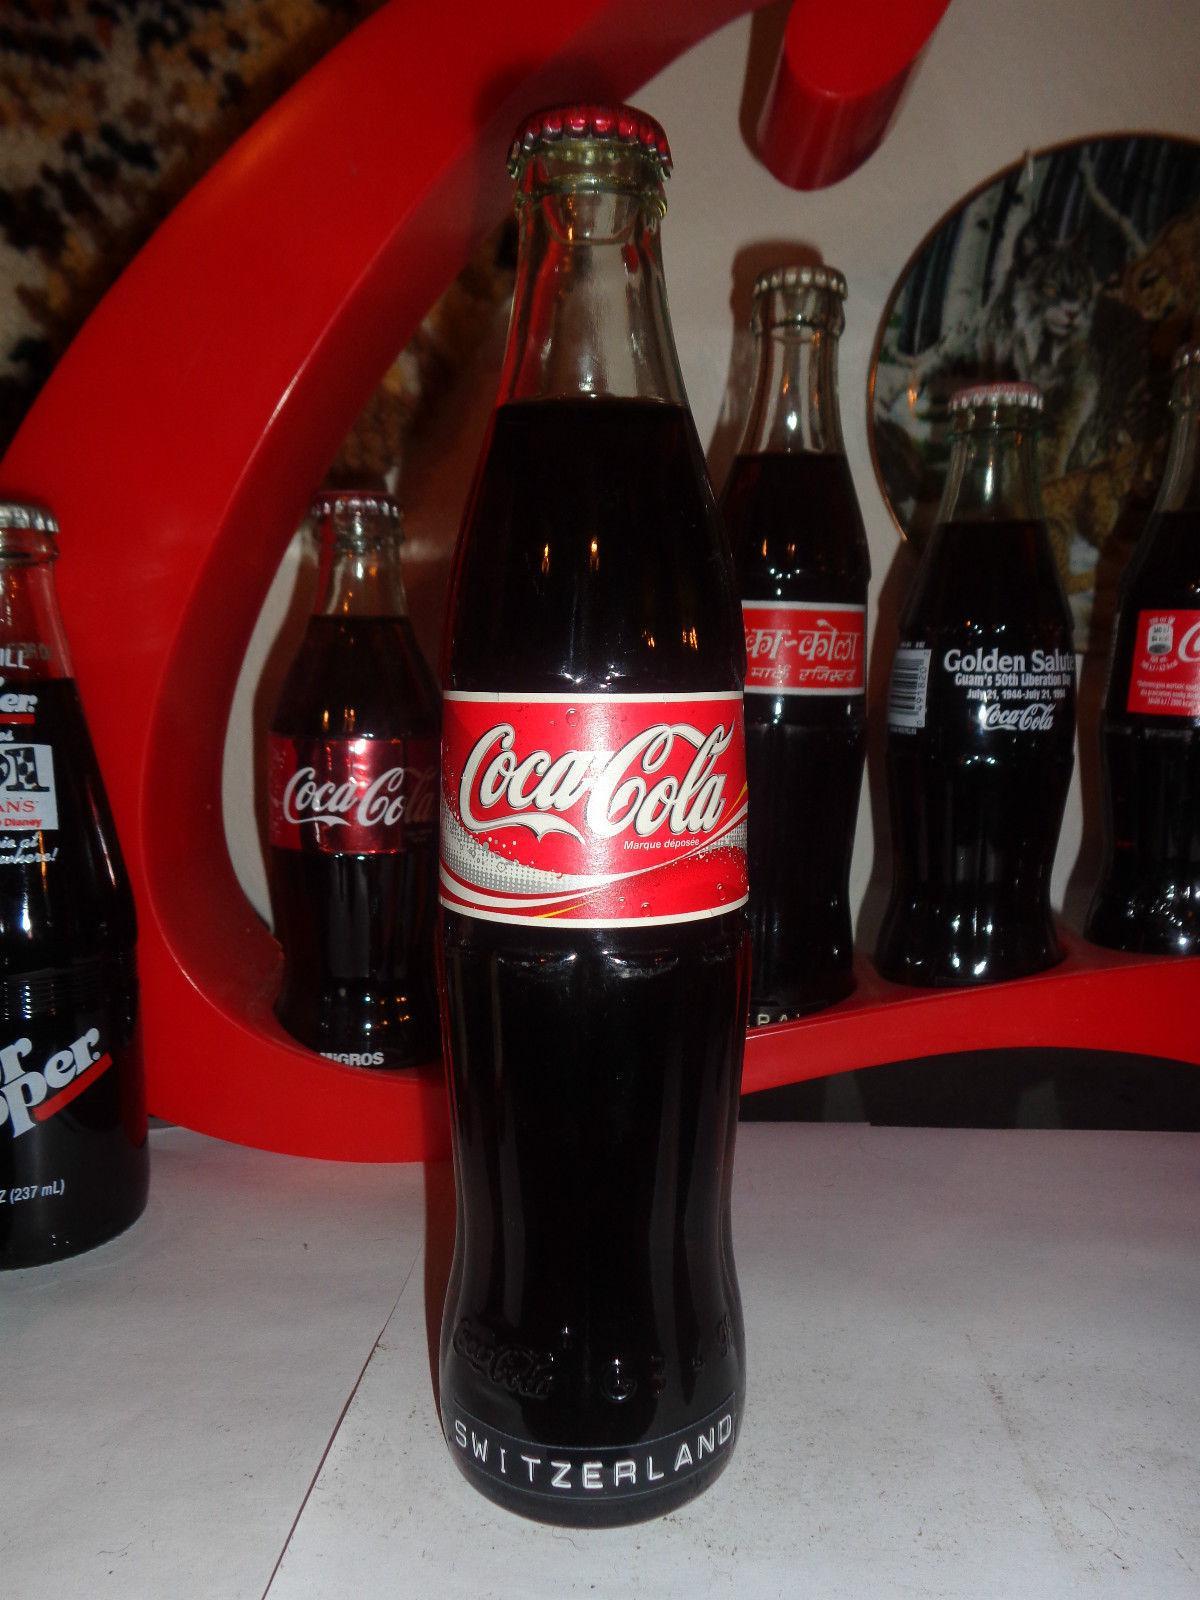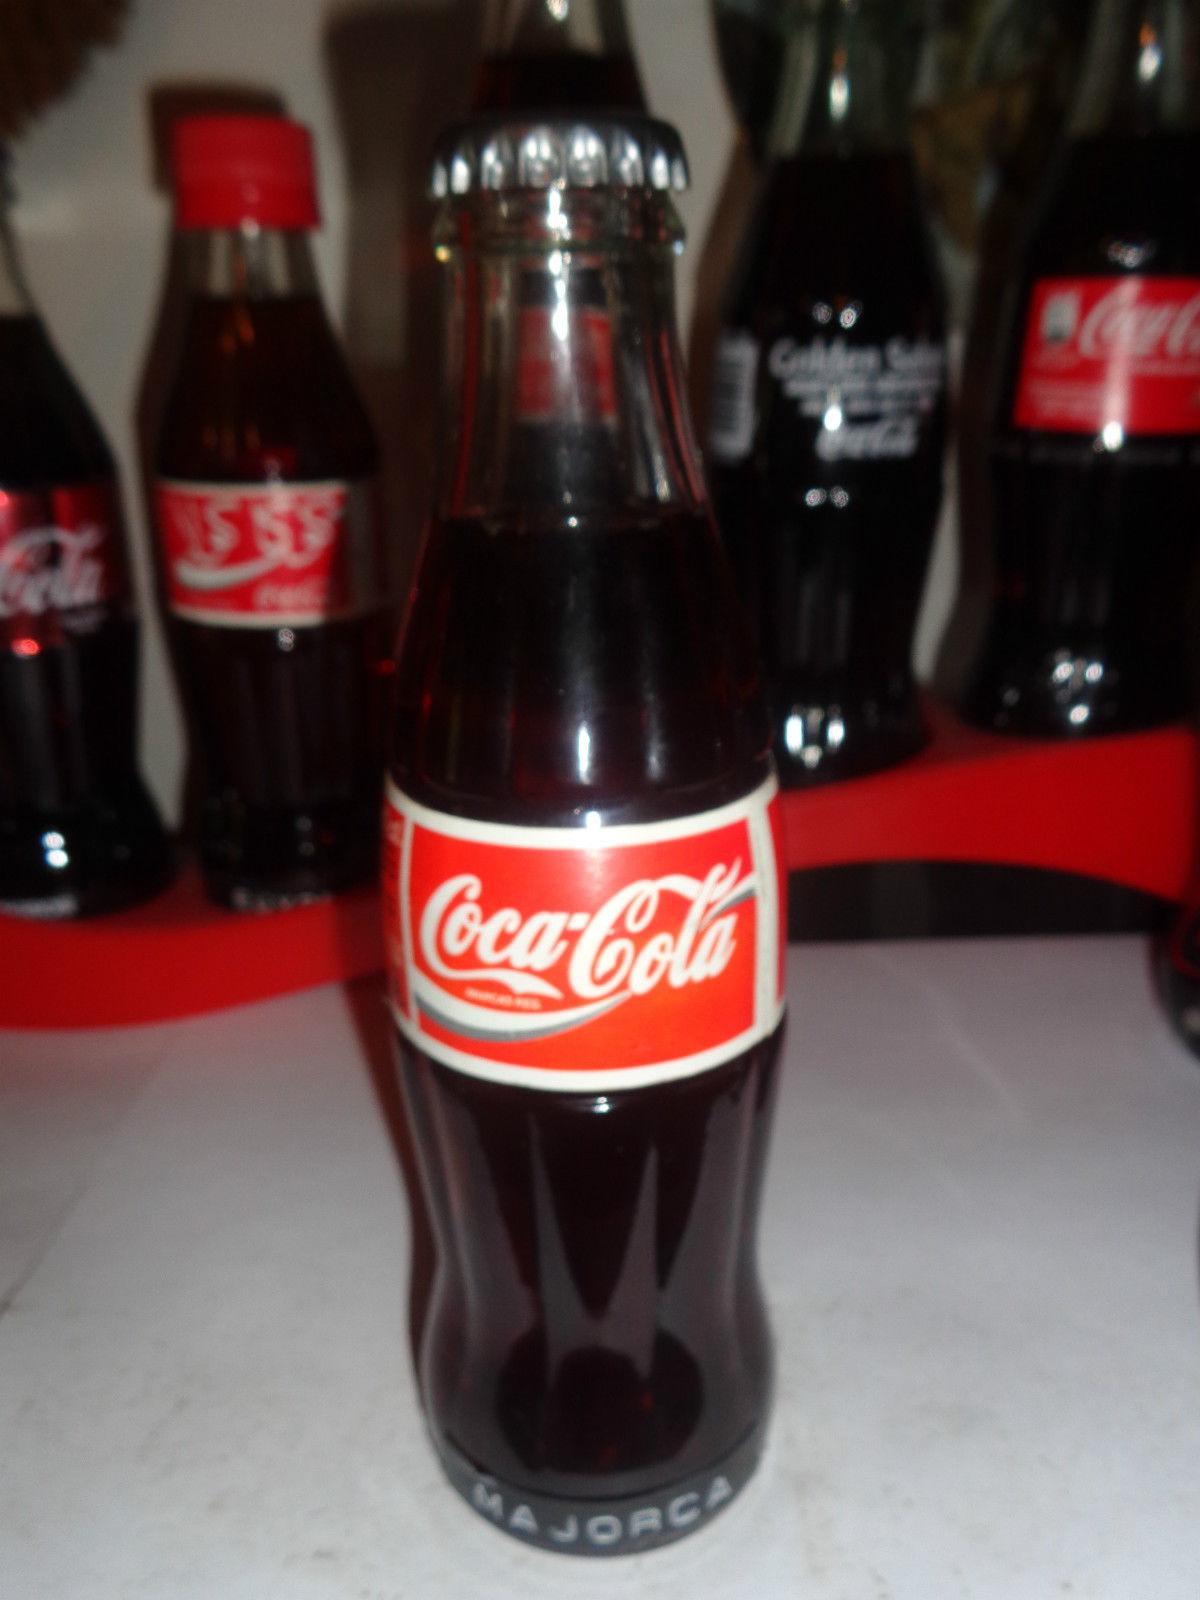The first image is the image on the left, the second image is the image on the right. Given the left and right images, does the statement "Two bottles are standing in front of all the others." hold true? Answer yes or no. Yes. The first image is the image on the left, the second image is the image on the right. Considering the images on both sides, is "The front most bottle in each of the images has a similarly colored label." valid? Answer yes or no. Yes. 